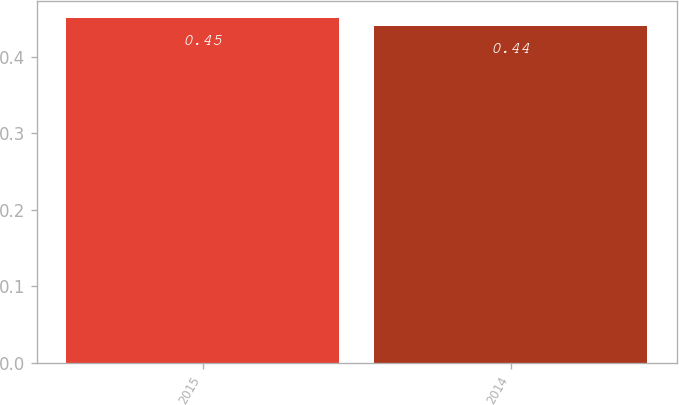Convert chart to OTSL. <chart><loc_0><loc_0><loc_500><loc_500><bar_chart><fcel>2015<fcel>2014<nl><fcel>0.45<fcel>0.44<nl></chart> 